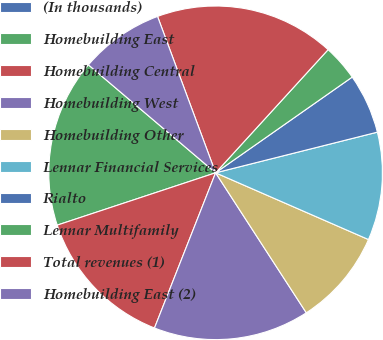Convert chart to OTSL. <chart><loc_0><loc_0><loc_500><loc_500><pie_chart><fcel>(In thousands)<fcel>Homebuilding East<fcel>Homebuilding Central<fcel>Homebuilding West<fcel>Homebuilding Other<fcel>Lennar Financial Services<fcel>Rialto<fcel>Lennar Multifamily<fcel>Total revenues (1)<fcel>Homebuilding East (2)<nl><fcel>0.0%<fcel>16.28%<fcel>13.95%<fcel>15.12%<fcel>9.3%<fcel>10.47%<fcel>5.81%<fcel>3.49%<fcel>17.44%<fcel>8.14%<nl></chart> 